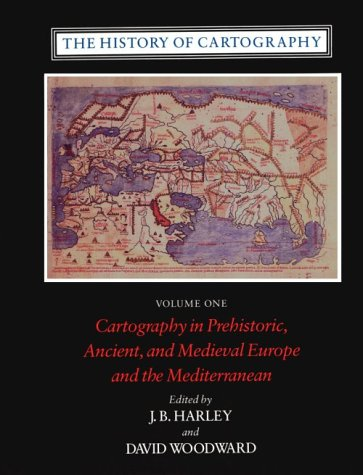Who edited this book and what might be their background? The book was edited by J.B. Harley and David Woodward, both renowned figures in historical cartography. Harley was known for his scholarly research in mapping practices, and Woodward brought extensive experience in studying the history and cultural influences on map-making. 